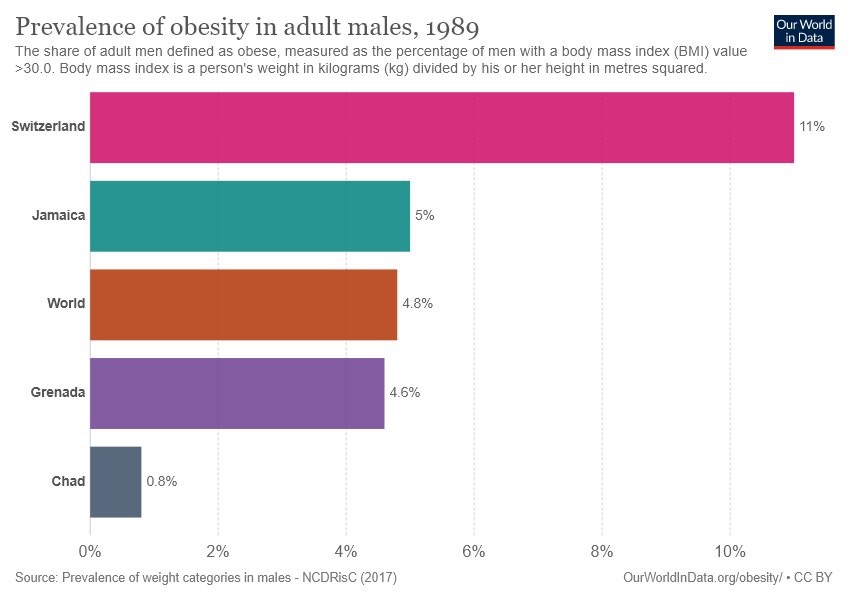Give some essential details in this illustration. The chart displays 4 countries. The average value of four countries is greater than the value of the world. 